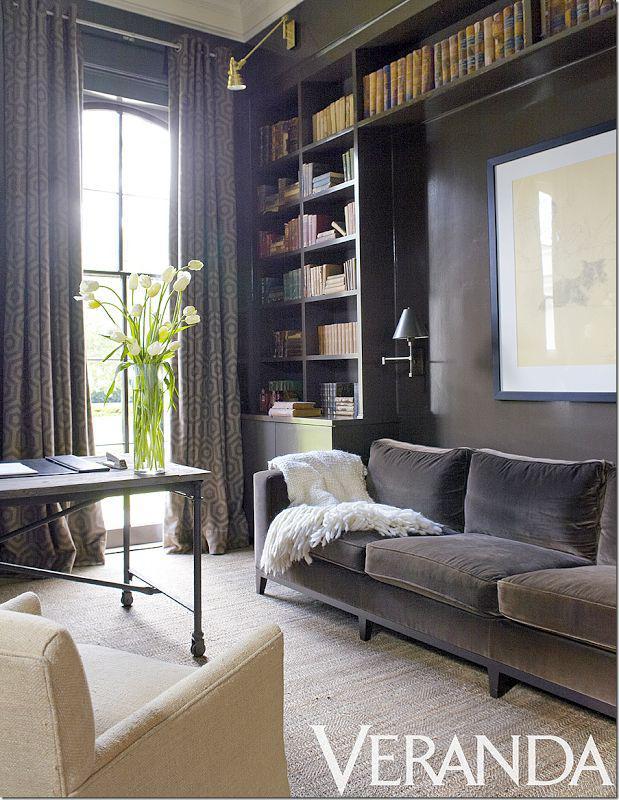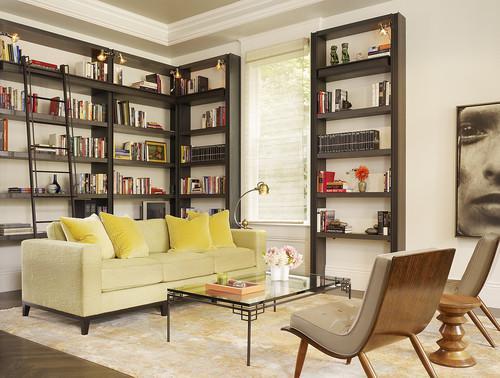The first image is the image on the left, the second image is the image on the right. Considering the images on both sides, is "One of the sofas has no coffee table before it in one of the images." valid? Answer yes or no. Yes. 